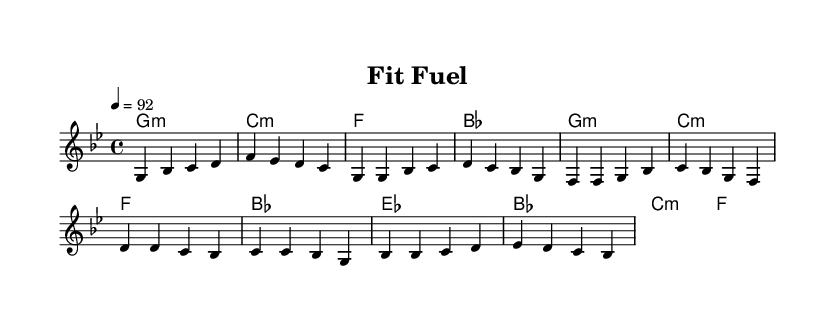What is the key signature of this music? The key signature is G minor, which contains two flats (B and E) that indicate the minor tonality.
Answer: G minor What is the time signature of this piece? The time signature is 4/4, which means there are four beats in each measure and the quarter note receives one beat.
Answer: 4/4 What is the tempo marking for this score? The tempo marking is quarter note equals 92, indicating that the piece should be played at a moderate speed.
Answer: 92 How many measures are in the verse of the melody? The verse consists of four measures, as indicated by the grouping of notes in the notation between the lyrics that correspond to that section.
Answer: Four measures What phrase repeats in the chorus? The phrase "Fit fuel, that's our rule" repeats in the chorus, emphasizing the song's focus on healthy eating and fitness.
Answer: Fit fuel, that's our rule What is the style or theme of this composition? The style or theme of this composition is health-conscious hip-hop, as it promotes clean eating and fitness through lyrics and rhythm.
Answer: Health-conscious hip-hop 